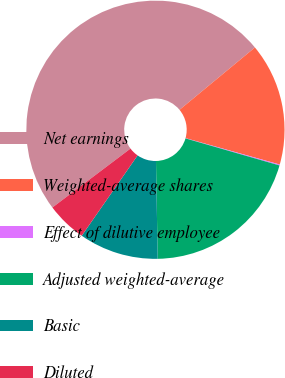<chart> <loc_0><loc_0><loc_500><loc_500><pie_chart><fcel>Net earnings<fcel>Weighted-average shares<fcel>Effect of dilutive employee<fcel>Adjusted weighted-average<fcel>Basic<fcel>Diluted<nl><fcel>49.29%<fcel>15.34%<fcel>0.12%<fcel>20.26%<fcel>9.95%<fcel>5.04%<nl></chart> 